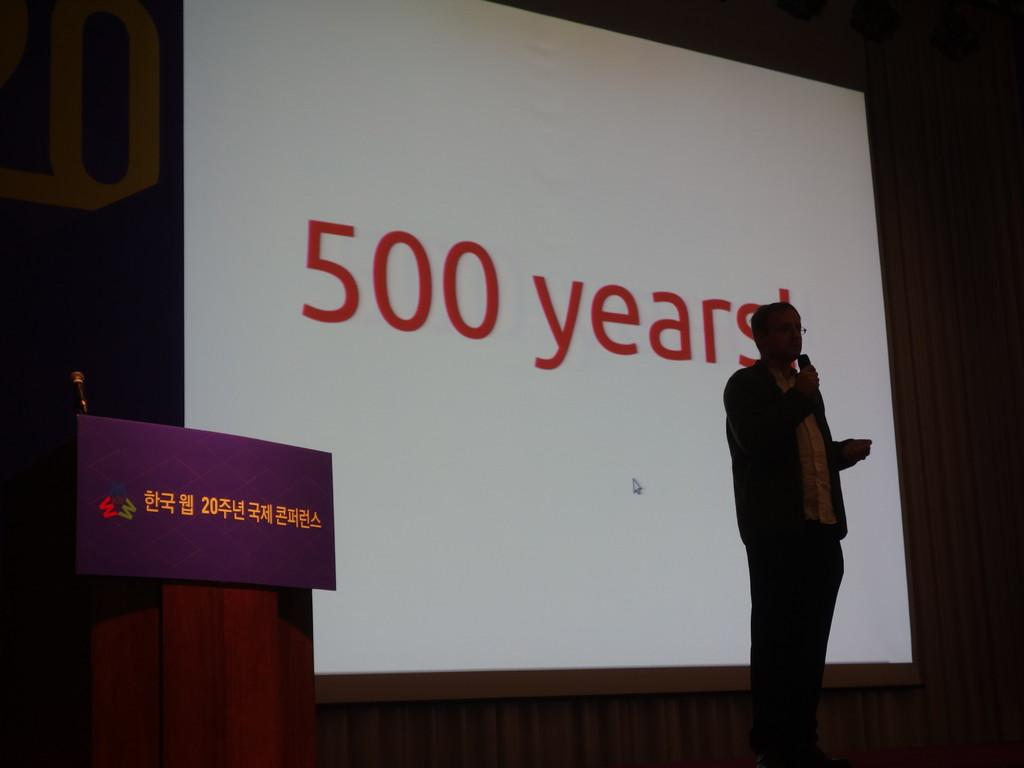Who is present in the image? There is a man in the image. What is the man doing in the image? The man is standing and holding a mic. What can be seen in the background of the image? There is a screen in the background of the image. What object is located on the left side of the image? There is a podium on the left side of the image. What type of hose is visible on the edge of the podium in the image? There is no hose present on the edge of the podium in the image. How many forks can be seen on the screen in the background? There are no forks visible on the screen in the background of the image. 